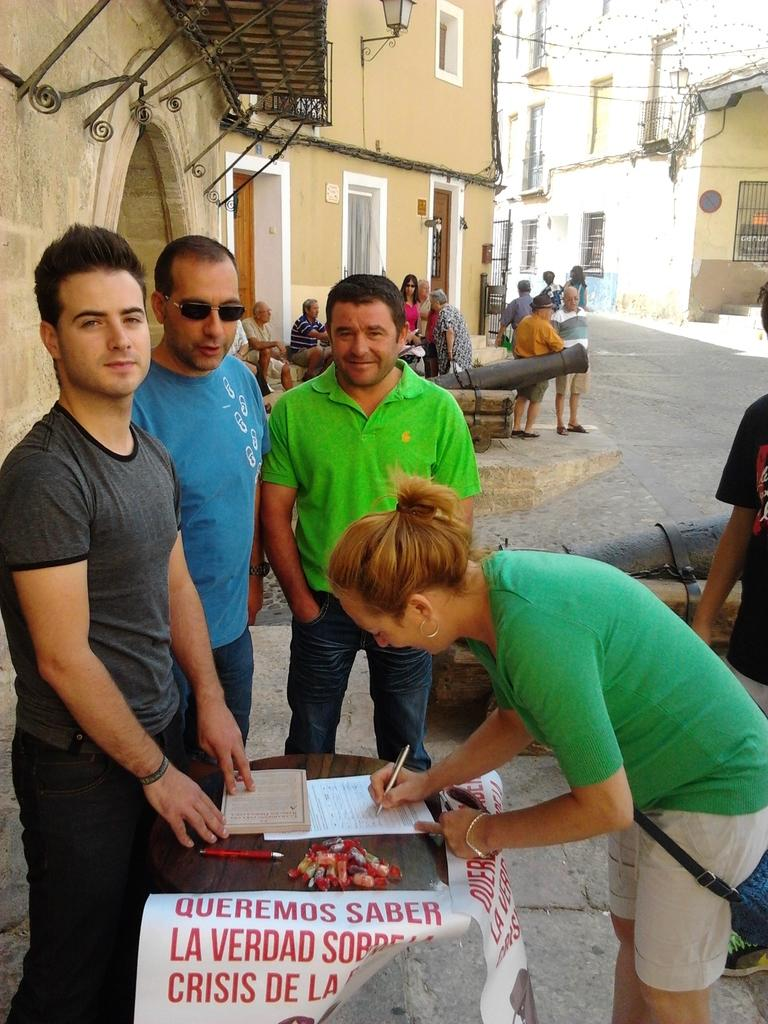What type of structures can be seen in the image? There are buildings in the image. Are there any people present in the image? Yes, there are people standing in the image. What is the woman in the image doing? The woman is writing on a paper in the image. Where is the woman sitting in the image? The woman is sitting at a table. Can you describe the man in the image? There is a man with sunglasses in the image. What type of question is the woman asking the banana in the image? There is no banana present in the image, so it is not possible to answer that question. 